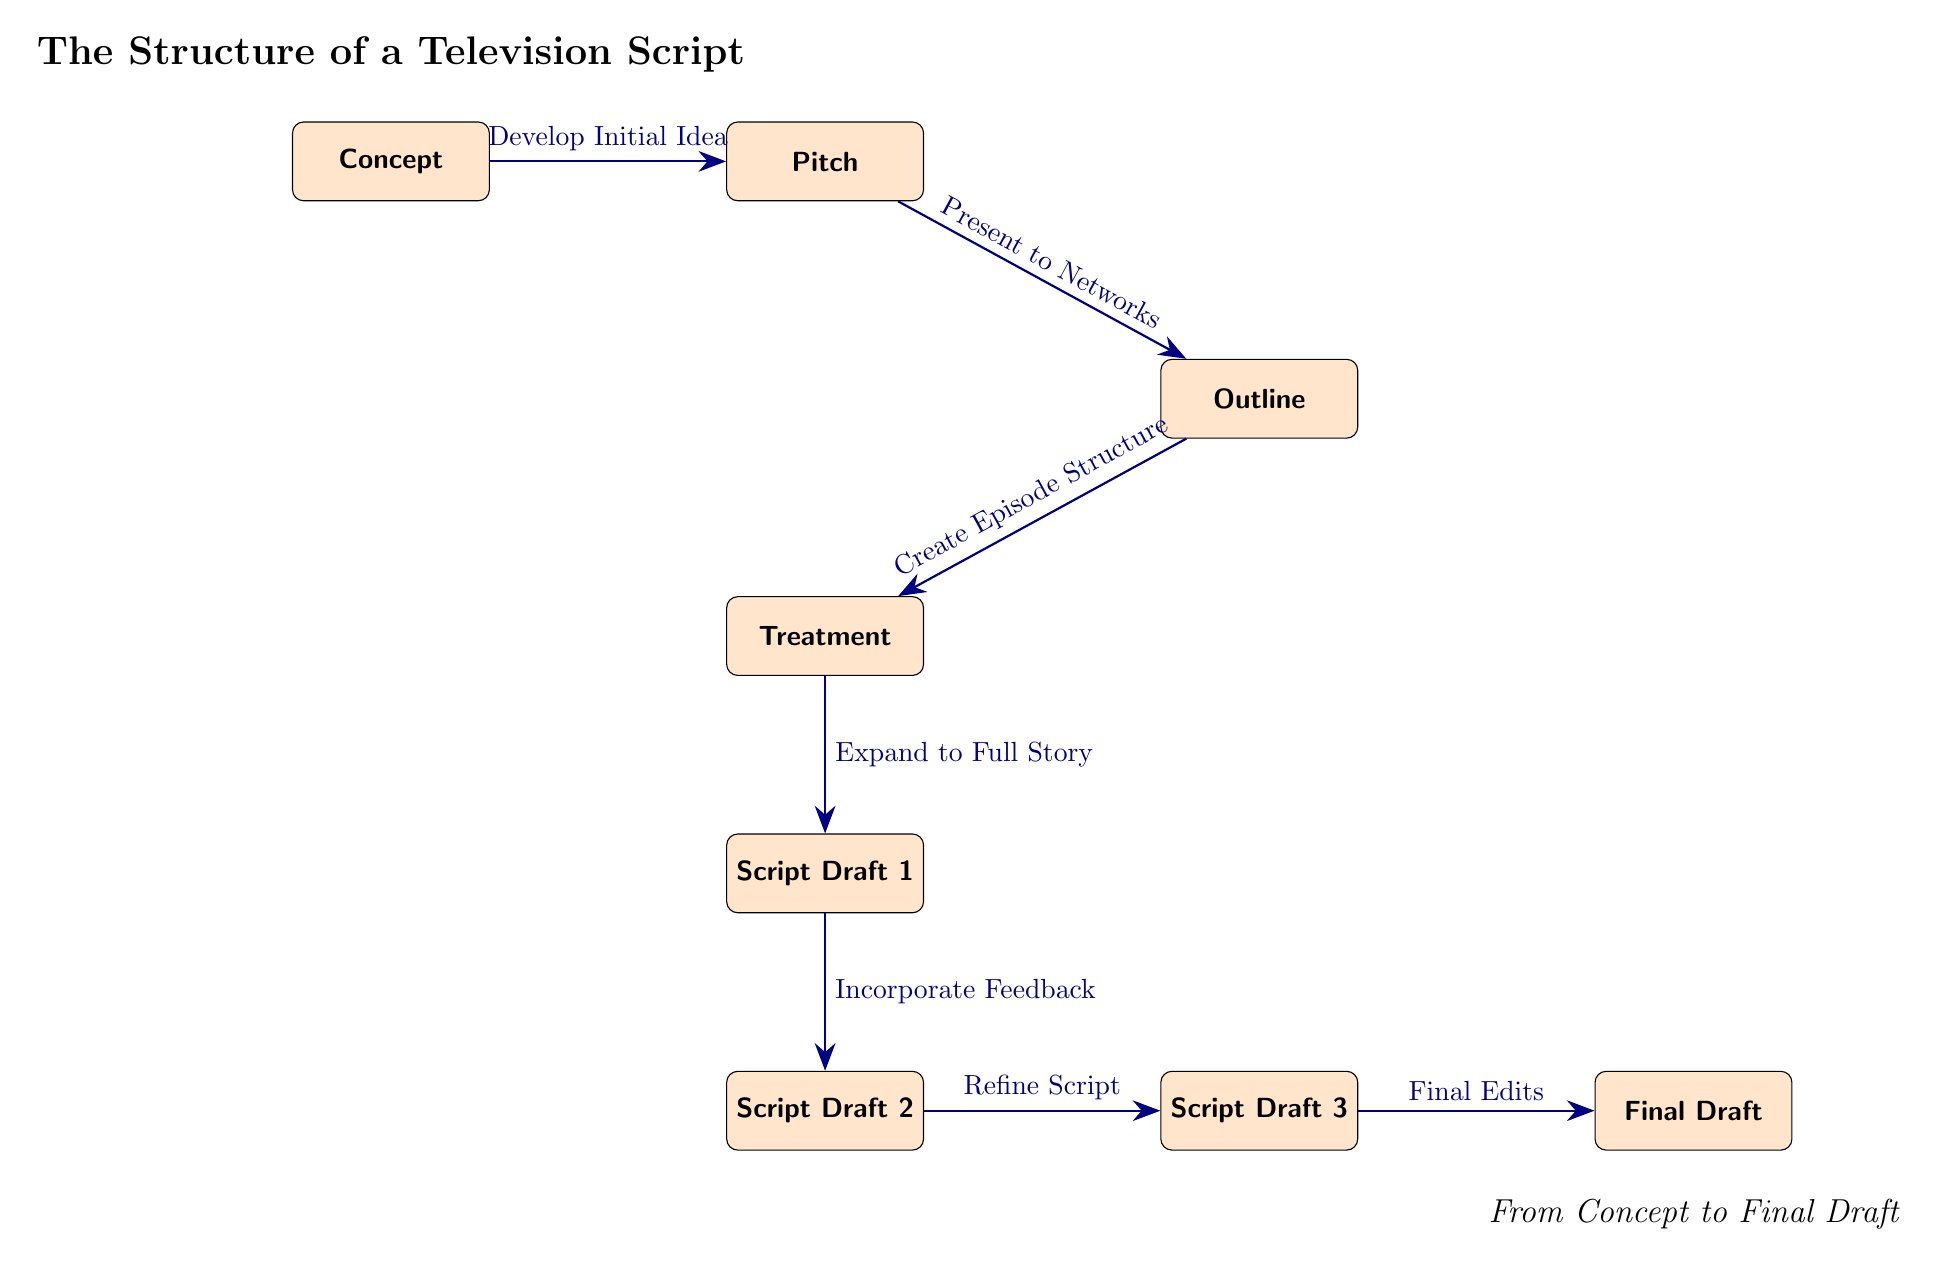What is the first node in the diagram? The first node, which represents the starting point of the television script process, is labeled "Concept." This is explicitly shown in the diagram as the topmost node.
Answer: Concept What is the label of the last node in the diagram? The last node in the diagram, which signifies the completion of the script process, is labeled "Final Draft." This is the bottom-right node in the flow of the diagram.
Answer: Final Draft How many total nodes are in the diagram? By counting the distinct labeled nodes represented in the diagram, which include Concept, Pitch, Outline, Treatment, Script Draft 1, Script Draft 2, Script Draft 3, and Final Draft, we find there are eight nodes in total.
Answer: 8 What is the action associated with the transition from Script Draft 1 to Script Draft 2? The transition from Script Draft 1 to Script Draft 2 is labeled "Incorporate Feedback." This describes the process that occurs between these two drafts in the context of script development.
Answer: Incorporate Feedback Which step involves presenting to networks? The step that involves presenting to networks is found as the transition from the "Pitch" node to the "Outline" node, indicated by the label "Present to Networks." This is the immediate next step after the Pitch.
Answer: Present to Networks How many drafts are indicated in the diagram? The diagram indicates a total of three drafts in the script development process, specifically: Script Draft 1, Script Draft 2, and Script Draft 3.
Answer: 3 What label connects the "Treatment" node to the "Script Draft 1" node? The label that connects the "Treatment" node to the "Script Draft 1" node is "Expand to Full Story." This action describes the development activity between the Treatment and the first script draft.
Answer: Expand to Full Story What type of diagram is this? The diagram is a Textbook Diagram, as it is structured to illustrate the process of creating a television script from concept to final draft, using nodes and directed arrows to show relationships and flow.
Answer: Textbook Diagram What is the third step after the Concept in the diagram? To determine the third step after "Concept," we observe the sequence of nodes. The first step is "Pitch," followed by "Outline," making the third step "Outline."
Answer: Outline 